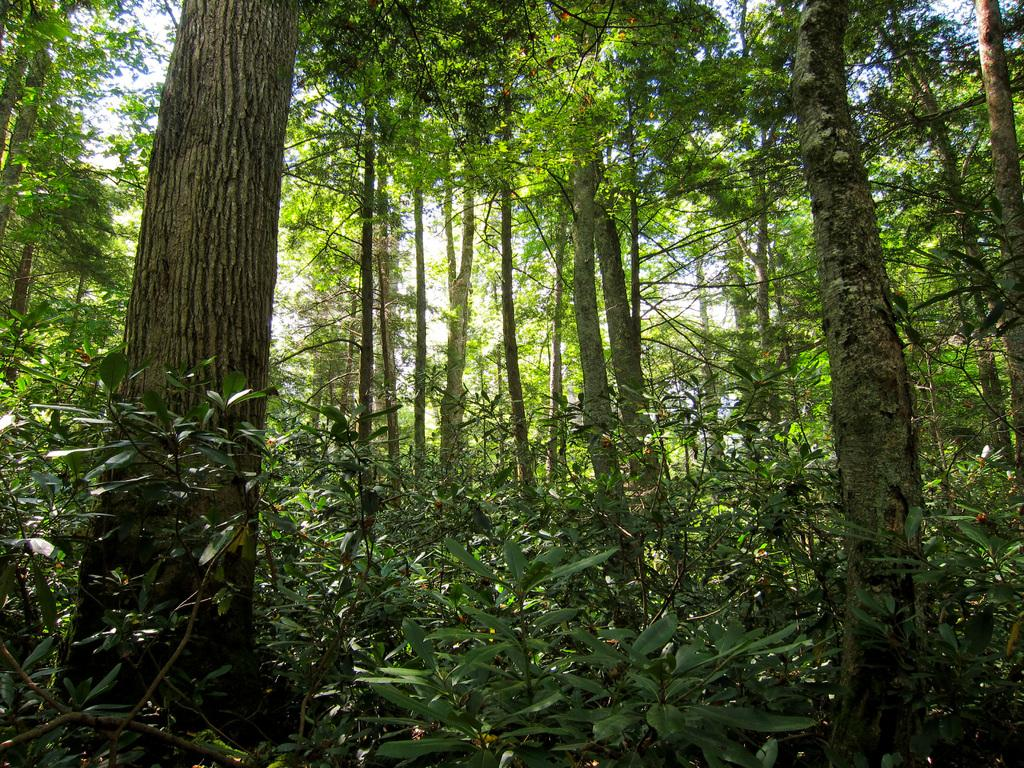What type of natural elements can be seen in the image? There are trees and plants in the image. Where are the trees and plants located in the image? The trees and plants are in the background of the image. What else can be seen in the background of the image? The sky is visible in the background of the image. Reasoning: Let'ing: Let's think step by step in order to produce the conversation. We start by identifying the main subject of the image, which is the trees and plants. Then, we describe their location within the image, noting that they are in the background. Finally, we mention the sky, which is also visible in the background. Absurd Question/Answer: What type of pear is hanging from the cloth in the image? There is no pear or cloth present in the image. What type of pear is hanging from the cloth in the image? There is no pear or cloth present in the image. 